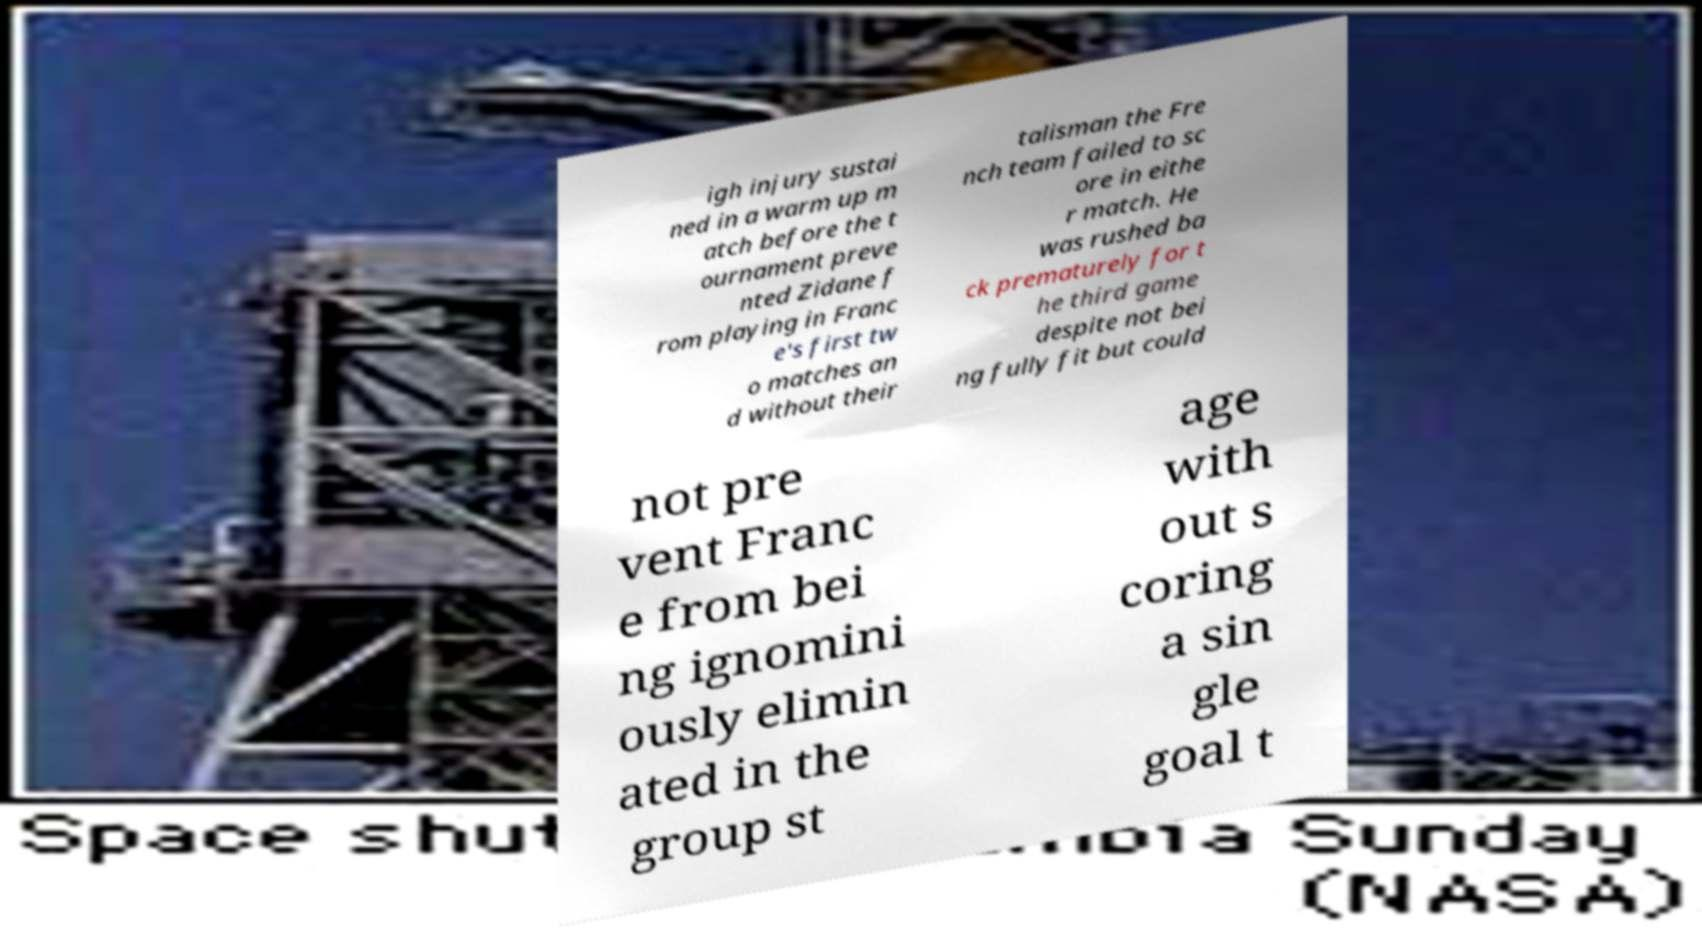I need the written content from this picture converted into text. Can you do that? igh injury sustai ned in a warm up m atch before the t ournament preve nted Zidane f rom playing in Franc e's first tw o matches an d without their talisman the Fre nch team failed to sc ore in eithe r match. He was rushed ba ck prematurely for t he third game despite not bei ng fully fit but could not pre vent Franc e from bei ng ignomini ously elimin ated in the group st age with out s coring a sin gle goal t 